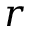Convert formula to latex. <formula><loc_0><loc_0><loc_500><loc_500>r</formula> 